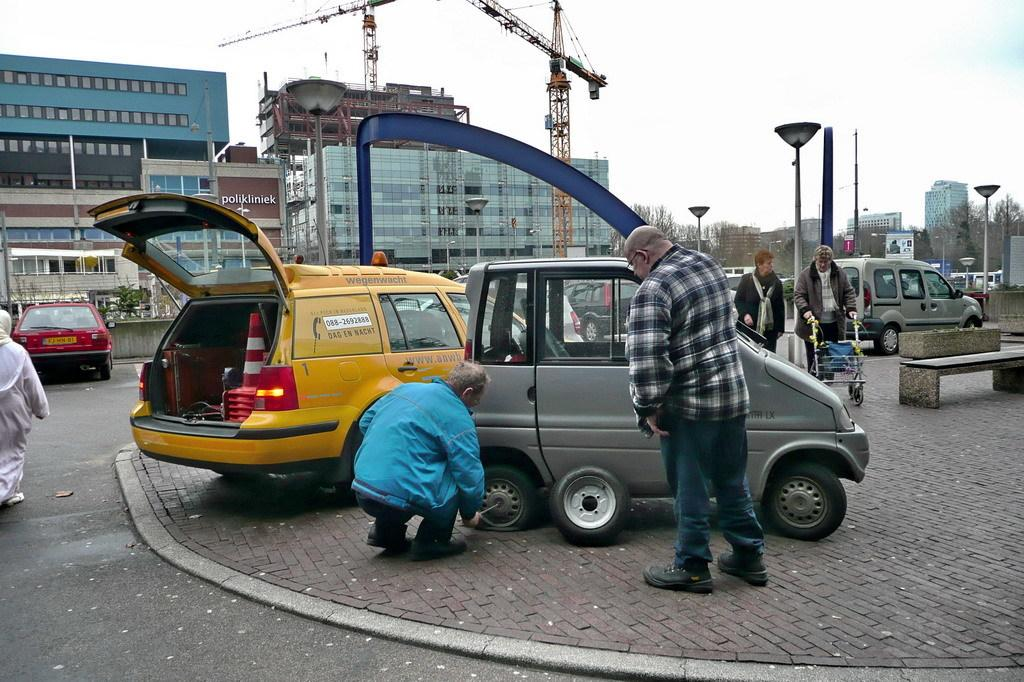Provide a one-sentence caption for the provided image. Two men are looking at a tire while one man fixes it next to a yellow car with a sticker that says wegenwacht. 